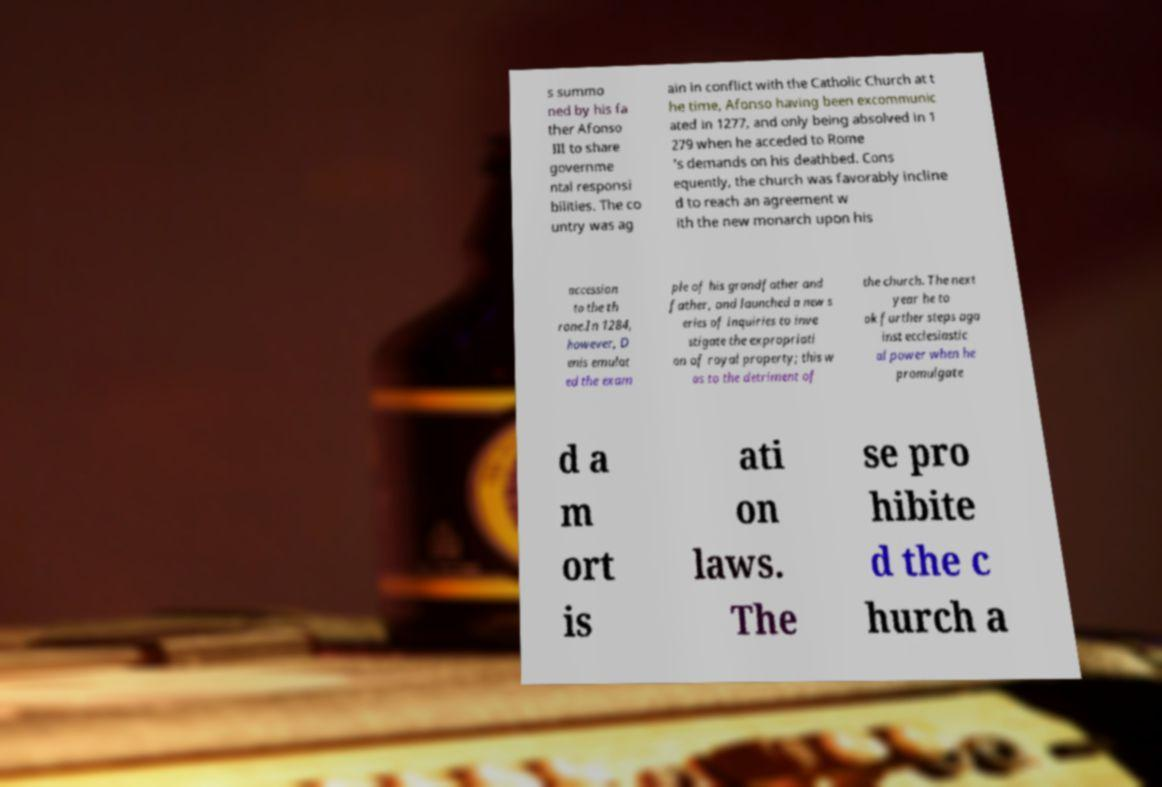For documentation purposes, I need the text within this image transcribed. Could you provide that? s summo ned by his fa ther Afonso III to share governme ntal responsi bilities. The co untry was ag ain in conflict with the Catholic Church at t he time, Afonso having been excommunic ated in 1277, and only being absolved in 1 279 when he acceded to Rome 's demands on his deathbed. Cons equently, the church was favorably incline d to reach an agreement w ith the new monarch upon his accession to the th rone.In 1284, however, D enis emulat ed the exam ple of his grandfather and father, and launched a new s eries of inquiries to inve stigate the expropriati on of royal property; this w as to the detriment of the church. The next year he to ok further steps aga inst ecclesiastic al power when he promulgate d a m ort is ati on laws. The se pro hibite d the c hurch a 